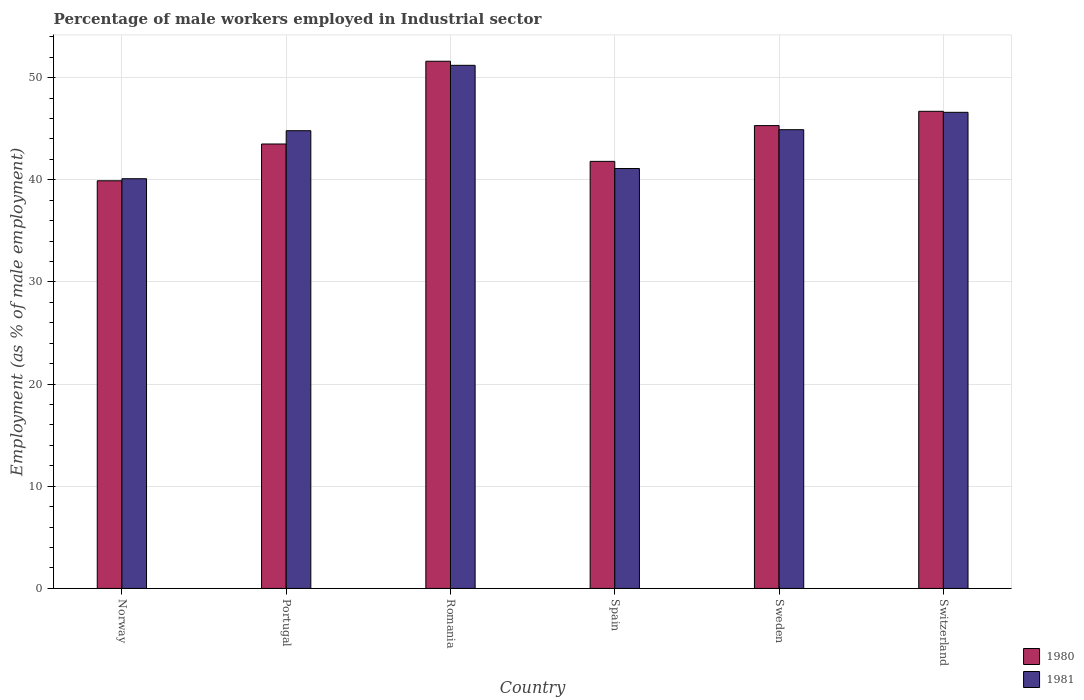How many different coloured bars are there?
Ensure brevity in your answer.  2. How many groups of bars are there?
Offer a terse response. 6. Are the number of bars per tick equal to the number of legend labels?
Your response must be concise. Yes. How many bars are there on the 3rd tick from the right?
Make the answer very short. 2. In how many cases, is the number of bars for a given country not equal to the number of legend labels?
Your answer should be very brief. 0. What is the percentage of male workers employed in Industrial sector in 1981 in Romania?
Provide a short and direct response. 51.2. Across all countries, what is the maximum percentage of male workers employed in Industrial sector in 1980?
Your answer should be compact. 51.6. Across all countries, what is the minimum percentage of male workers employed in Industrial sector in 1980?
Your response must be concise. 39.9. In which country was the percentage of male workers employed in Industrial sector in 1981 maximum?
Your response must be concise. Romania. In which country was the percentage of male workers employed in Industrial sector in 1981 minimum?
Make the answer very short. Norway. What is the total percentage of male workers employed in Industrial sector in 1981 in the graph?
Ensure brevity in your answer.  268.7. What is the difference between the percentage of male workers employed in Industrial sector in 1980 in Spain and that in Switzerland?
Provide a succinct answer. -4.9. What is the difference between the percentage of male workers employed in Industrial sector in 1980 in Norway and the percentage of male workers employed in Industrial sector in 1981 in Spain?
Make the answer very short. -1.2. What is the average percentage of male workers employed in Industrial sector in 1981 per country?
Offer a very short reply. 44.78. What is the difference between the percentage of male workers employed in Industrial sector of/in 1981 and percentage of male workers employed in Industrial sector of/in 1980 in Spain?
Offer a terse response. -0.7. What is the ratio of the percentage of male workers employed in Industrial sector in 1980 in Romania to that in Switzerland?
Your answer should be compact. 1.1. Is the difference between the percentage of male workers employed in Industrial sector in 1981 in Romania and Switzerland greater than the difference between the percentage of male workers employed in Industrial sector in 1980 in Romania and Switzerland?
Your response must be concise. No. What is the difference between the highest and the second highest percentage of male workers employed in Industrial sector in 1981?
Your answer should be compact. 6.3. What is the difference between the highest and the lowest percentage of male workers employed in Industrial sector in 1980?
Give a very brief answer. 11.7. How many bars are there?
Offer a terse response. 12. What is the difference between two consecutive major ticks on the Y-axis?
Your answer should be very brief. 10. Does the graph contain grids?
Provide a succinct answer. Yes. How many legend labels are there?
Your answer should be compact. 2. How are the legend labels stacked?
Provide a succinct answer. Vertical. What is the title of the graph?
Ensure brevity in your answer.  Percentage of male workers employed in Industrial sector. Does "2005" appear as one of the legend labels in the graph?
Ensure brevity in your answer.  No. What is the label or title of the Y-axis?
Keep it short and to the point. Employment (as % of male employment). What is the Employment (as % of male employment) of 1980 in Norway?
Provide a succinct answer. 39.9. What is the Employment (as % of male employment) of 1981 in Norway?
Offer a very short reply. 40.1. What is the Employment (as % of male employment) in 1980 in Portugal?
Provide a short and direct response. 43.5. What is the Employment (as % of male employment) in 1981 in Portugal?
Offer a terse response. 44.8. What is the Employment (as % of male employment) of 1980 in Romania?
Your answer should be very brief. 51.6. What is the Employment (as % of male employment) in 1981 in Romania?
Provide a short and direct response. 51.2. What is the Employment (as % of male employment) of 1980 in Spain?
Give a very brief answer. 41.8. What is the Employment (as % of male employment) of 1981 in Spain?
Provide a short and direct response. 41.1. What is the Employment (as % of male employment) in 1980 in Sweden?
Offer a terse response. 45.3. What is the Employment (as % of male employment) in 1981 in Sweden?
Your response must be concise. 44.9. What is the Employment (as % of male employment) of 1980 in Switzerland?
Provide a succinct answer. 46.7. What is the Employment (as % of male employment) in 1981 in Switzerland?
Provide a short and direct response. 46.6. Across all countries, what is the maximum Employment (as % of male employment) of 1980?
Ensure brevity in your answer.  51.6. Across all countries, what is the maximum Employment (as % of male employment) of 1981?
Provide a short and direct response. 51.2. Across all countries, what is the minimum Employment (as % of male employment) in 1980?
Your answer should be compact. 39.9. Across all countries, what is the minimum Employment (as % of male employment) of 1981?
Provide a short and direct response. 40.1. What is the total Employment (as % of male employment) of 1980 in the graph?
Make the answer very short. 268.8. What is the total Employment (as % of male employment) of 1981 in the graph?
Provide a succinct answer. 268.7. What is the difference between the Employment (as % of male employment) in 1980 in Norway and that in Portugal?
Your answer should be compact. -3.6. What is the difference between the Employment (as % of male employment) of 1981 in Norway and that in Spain?
Offer a terse response. -1. What is the difference between the Employment (as % of male employment) of 1980 in Norway and that in Sweden?
Your answer should be compact. -5.4. What is the difference between the Employment (as % of male employment) in 1980 in Norway and that in Switzerland?
Your answer should be compact. -6.8. What is the difference between the Employment (as % of male employment) in 1981 in Norway and that in Switzerland?
Provide a succinct answer. -6.5. What is the difference between the Employment (as % of male employment) of 1981 in Portugal and that in Romania?
Your response must be concise. -6.4. What is the difference between the Employment (as % of male employment) of 1980 in Portugal and that in Spain?
Your answer should be compact. 1.7. What is the difference between the Employment (as % of male employment) of 1981 in Portugal and that in Sweden?
Your answer should be compact. -0.1. What is the difference between the Employment (as % of male employment) of 1981 in Romania and that in Sweden?
Your answer should be very brief. 6.3. What is the difference between the Employment (as % of male employment) of 1980 in Romania and that in Switzerland?
Make the answer very short. 4.9. What is the difference between the Employment (as % of male employment) of 1981 in Romania and that in Switzerland?
Offer a very short reply. 4.6. What is the difference between the Employment (as % of male employment) in 1980 in Norway and the Employment (as % of male employment) in 1981 in Sweden?
Ensure brevity in your answer.  -5. What is the difference between the Employment (as % of male employment) in 1980 in Norway and the Employment (as % of male employment) in 1981 in Switzerland?
Offer a terse response. -6.7. What is the difference between the Employment (as % of male employment) in 1980 in Portugal and the Employment (as % of male employment) in 1981 in Spain?
Give a very brief answer. 2.4. What is the difference between the Employment (as % of male employment) in 1980 in Romania and the Employment (as % of male employment) in 1981 in Switzerland?
Provide a succinct answer. 5. What is the difference between the Employment (as % of male employment) of 1980 in Spain and the Employment (as % of male employment) of 1981 in Sweden?
Give a very brief answer. -3.1. What is the difference between the Employment (as % of male employment) of 1980 in Sweden and the Employment (as % of male employment) of 1981 in Switzerland?
Ensure brevity in your answer.  -1.3. What is the average Employment (as % of male employment) of 1980 per country?
Make the answer very short. 44.8. What is the average Employment (as % of male employment) of 1981 per country?
Make the answer very short. 44.78. What is the difference between the Employment (as % of male employment) of 1980 and Employment (as % of male employment) of 1981 in Romania?
Keep it short and to the point. 0.4. What is the difference between the Employment (as % of male employment) in 1980 and Employment (as % of male employment) in 1981 in Sweden?
Provide a short and direct response. 0.4. What is the ratio of the Employment (as % of male employment) of 1980 in Norway to that in Portugal?
Offer a very short reply. 0.92. What is the ratio of the Employment (as % of male employment) of 1981 in Norway to that in Portugal?
Your answer should be compact. 0.9. What is the ratio of the Employment (as % of male employment) of 1980 in Norway to that in Romania?
Your answer should be very brief. 0.77. What is the ratio of the Employment (as % of male employment) of 1981 in Norway to that in Romania?
Your answer should be compact. 0.78. What is the ratio of the Employment (as % of male employment) of 1980 in Norway to that in Spain?
Give a very brief answer. 0.95. What is the ratio of the Employment (as % of male employment) in 1981 in Norway to that in Spain?
Your answer should be very brief. 0.98. What is the ratio of the Employment (as % of male employment) of 1980 in Norway to that in Sweden?
Offer a very short reply. 0.88. What is the ratio of the Employment (as % of male employment) in 1981 in Norway to that in Sweden?
Your answer should be compact. 0.89. What is the ratio of the Employment (as % of male employment) of 1980 in Norway to that in Switzerland?
Make the answer very short. 0.85. What is the ratio of the Employment (as % of male employment) in 1981 in Norway to that in Switzerland?
Your answer should be very brief. 0.86. What is the ratio of the Employment (as % of male employment) of 1980 in Portugal to that in Romania?
Your response must be concise. 0.84. What is the ratio of the Employment (as % of male employment) in 1980 in Portugal to that in Spain?
Keep it short and to the point. 1.04. What is the ratio of the Employment (as % of male employment) of 1981 in Portugal to that in Spain?
Offer a very short reply. 1.09. What is the ratio of the Employment (as % of male employment) of 1980 in Portugal to that in Sweden?
Your answer should be compact. 0.96. What is the ratio of the Employment (as % of male employment) of 1981 in Portugal to that in Sweden?
Give a very brief answer. 1. What is the ratio of the Employment (as % of male employment) of 1980 in Portugal to that in Switzerland?
Offer a very short reply. 0.93. What is the ratio of the Employment (as % of male employment) of 1981 in Portugal to that in Switzerland?
Your answer should be very brief. 0.96. What is the ratio of the Employment (as % of male employment) in 1980 in Romania to that in Spain?
Provide a short and direct response. 1.23. What is the ratio of the Employment (as % of male employment) of 1981 in Romania to that in Spain?
Your answer should be compact. 1.25. What is the ratio of the Employment (as % of male employment) of 1980 in Romania to that in Sweden?
Your answer should be compact. 1.14. What is the ratio of the Employment (as % of male employment) in 1981 in Romania to that in Sweden?
Provide a short and direct response. 1.14. What is the ratio of the Employment (as % of male employment) of 1980 in Romania to that in Switzerland?
Keep it short and to the point. 1.1. What is the ratio of the Employment (as % of male employment) of 1981 in Romania to that in Switzerland?
Provide a succinct answer. 1.1. What is the ratio of the Employment (as % of male employment) in 1980 in Spain to that in Sweden?
Provide a short and direct response. 0.92. What is the ratio of the Employment (as % of male employment) of 1981 in Spain to that in Sweden?
Make the answer very short. 0.92. What is the ratio of the Employment (as % of male employment) in 1980 in Spain to that in Switzerland?
Make the answer very short. 0.9. What is the ratio of the Employment (as % of male employment) in 1981 in Spain to that in Switzerland?
Provide a short and direct response. 0.88. What is the ratio of the Employment (as % of male employment) of 1981 in Sweden to that in Switzerland?
Make the answer very short. 0.96. 